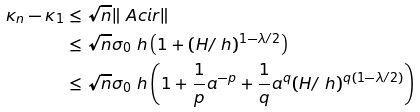Convert formula to latex. <formula><loc_0><loc_0><loc_500><loc_500>\kappa _ { n } - \kappa _ { 1 } & \leq \sqrt { n } \| \ A c i r \| \\ & \leq \sqrt { n } \sigma _ { 0 } \ h \left ( 1 + ( H / \ h ) ^ { 1 - \lambda / 2 } \right ) \\ & \leq \sqrt { n } \sigma _ { 0 } \ h \left ( 1 + \frac { 1 } { p } a ^ { - p } + \frac { 1 } { q } a ^ { q } ( H / \ h ) ^ { q ( 1 - \lambda / 2 ) } \right )</formula> 